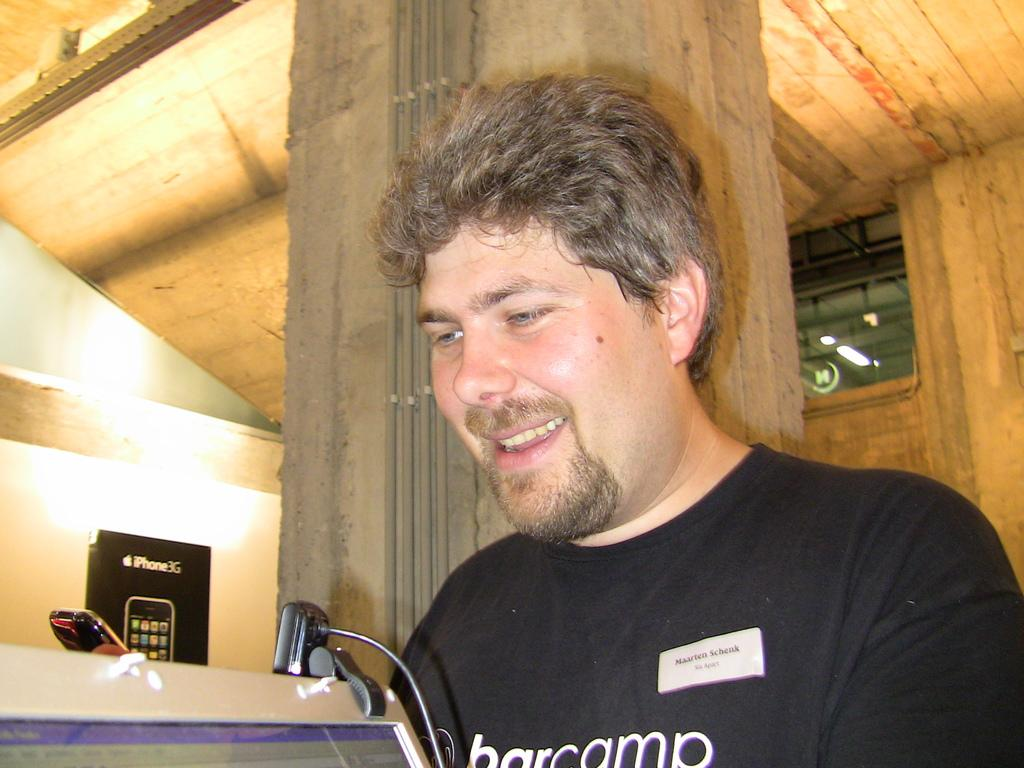What is the main subject of the image? There is a man in the image. What is the man wearing? The man is wearing a black t-shirt. What is the man's facial expression? The man is smiling. What can be seen in the background of the image? There is a pillar and other objects in the background of the image. What type of collar is the man wearing in the image? The man is not wearing a collar in the image, as he is wearing a t-shirt. How does the man process information in the image? There is no indication in the image of how the man processes information, as it only shows his appearance and the background. 